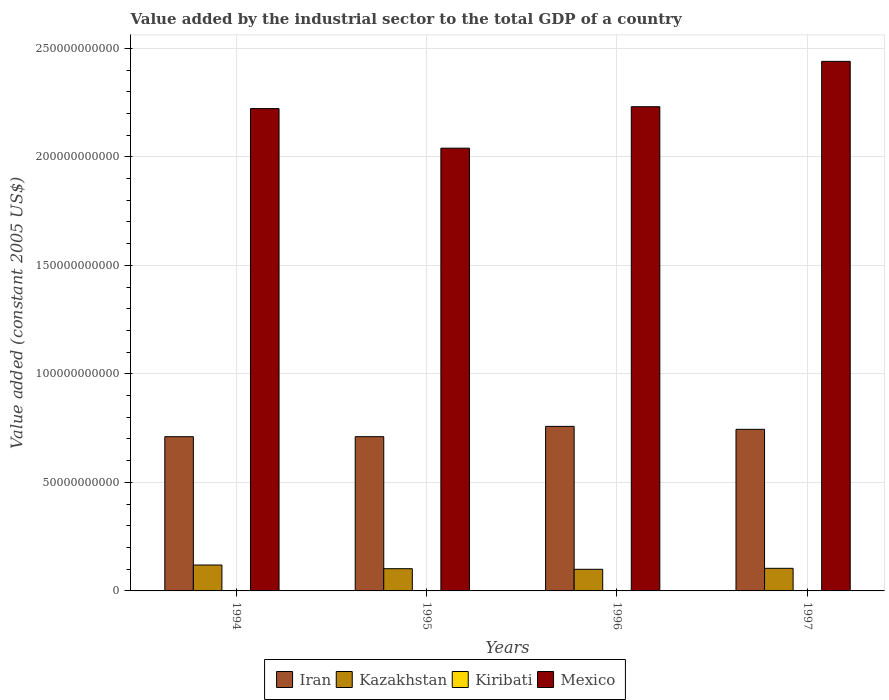How many different coloured bars are there?
Your answer should be compact. 4. Are the number of bars per tick equal to the number of legend labels?
Give a very brief answer. Yes. How many bars are there on the 2nd tick from the right?
Give a very brief answer. 4. In how many cases, is the number of bars for a given year not equal to the number of legend labels?
Provide a succinct answer. 0. What is the value added by the industrial sector in Kiribati in 1996?
Your answer should be compact. 4.96e+06. Across all years, what is the maximum value added by the industrial sector in Mexico?
Your answer should be compact. 2.44e+11. Across all years, what is the minimum value added by the industrial sector in Kiribati?
Your answer should be compact. 4.96e+06. What is the total value added by the industrial sector in Mexico in the graph?
Ensure brevity in your answer.  8.93e+11. What is the difference between the value added by the industrial sector in Mexico in 1994 and that in 1997?
Offer a terse response. -2.18e+1. What is the difference between the value added by the industrial sector in Kazakhstan in 1996 and the value added by the industrial sector in Kiribati in 1995?
Offer a very short reply. 9.96e+09. What is the average value added by the industrial sector in Kazakhstan per year?
Ensure brevity in your answer.  1.06e+1. In the year 1994, what is the difference between the value added by the industrial sector in Kiribati and value added by the industrial sector in Iran?
Provide a short and direct response. -7.11e+1. In how many years, is the value added by the industrial sector in Kazakhstan greater than 40000000000 US$?
Ensure brevity in your answer.  0. What is the ratio of the value added by the industrial sector in Kiribati in 1994 to that in 1997?
Provide a succinct answer. 0.96. Is the value added by the industrial sector in Iran in 1994 less than that in 1996?
Your answer should be very brief. Yes. Is the difference between the value added by the industrial sector in Kiribati in 1995 and 1997 greater than the difference between the value added by the industrial sector in Iran in 1995 and 1997?
Your response must be concise. Yes. What is the difference between the highest and the second highest value added by the industrial sector in Mexico?
Offer a very short reply. 2.09e+1. What is the difference between the highest and the lowest value added by the industrial sector in Kiribati?
Provide a succinct answer. 2.42e+05. Is the sum of the value added by the industrial sector in Kiribati in 1996 and 1997 greater than the maximum value added by the industrial sector in Iran across all years?
Offer a very short reply. No. What does the 1st bar from the left in 1997 represents?
Give a very brief answer. Iran. What does the 4th bar from the right in 1994 represents?
Keep it short and to the point. Iran. Is it the case that in every year, the sum of the value added by the industrial sector in Mexico and value added by the industrial sector in Kazakhstan is greater than the value added by the industrial sector in Kiribati?
Make the answer very short. Yes. How many bars are there?
Keep it short and to the point. 16. Are the values on the major ticks of Y-axis written in scientific E-notation?
Make the answer very short. No. Does the graph contain any zero values?
Provide a short and direct response. No. Does the graph contain grids?
Your answer should be very brief. Yes. How many legend labels are there?
Offer a terse response. 4. What is the title of the graph?
Your response must be concise. Value added by the industrial sector to the total GDP of a country. What is the label or title of the Y-axis?
Your answer should be very brief. Value added (constant 2005 US$). What is the Value added (constant 2005 US$) of Iran in 1994?
Your response must be concise. 7.11e+1. What is the Value added (constant 2005 US$) of Kazakhstan in 1994?
Your answer should be very brief. 1.19e+1. What is the Value added (constant 2005 US$) in Kiribati in 1994?
Your answer should be compact. 4.98e+06. What is the Value added (constant 2005 US$) of Mexico in 1994?
Your answer should be compact. 2.22e+11. What is the Value added (constant 2005 US$) of Iran in 1995?
Ensure brevity in your answer.  7.11e+1. What is the Value added (constant 2005 US$) in Kazakhstan in 1995?
Provide a short and direct response. 1.02e+1. What is the Value added (constant 2005 US$) of Kiribati in 1995?
Ensure brevity in your answer.  4.99e+06. What is the Value added (constant 2005 US$) of Mexico in 1995?
Give a very brief answer. 2.04e+11. What is the Value added (constant 2005 US$) of Iran in 1996?
Provide a succinct answer. 7.58e+1. What is the Value added (constant 2005 US$) of Kazakhstan in 1996?
Keep it short and to the point. 9.96e+09. What is the Value added (constant 2005 US$) in Kiribati in 1996?
Your answer should be compact. 4.96e+06. What is the Value added (constant 2005 US$) in Mexico in 1996?
Make the answer very short. 2.23e+11. What is the Value added (constant 2005 US$) in Iran in 1997?
Your answer should be compact. 7.45e+1. What is the Value added (constant 2005 US$) in Kazakhstan in 1997?
Your answer should be compact. 1.04e+1. What is the Value added (constant 2005 US$) of Kiribati in 1997?
Offer a terse response. 5.20e+06. What is the Value added (constant 2005 US$) of Mexico in 1997?
Your answer should be very brief. 2.44e+11. Across all years, what is the maximum Value added (constant 2005 US$) of Iran?
Provide a succinct answer. 7.58e+1. Across all years, what is the maximum Value added (constant 2005 US$) of Kazakhstan?
Make the answer very short. 1.19e+1. Across all years, what is the maximum Value added (constant 2005 US$) of Kiribati?
Give a very brief answer. 5.20e+06. Across all years, what is the maximum Value added (constant 2005 US$) of Mexico?
Your response must be concise. 2.44e+11. Across all years, what is the minimum Value added (constant 2005 US$) in Iran?
Provide a succinct answer. 7.11e+1. Across all years, what is the minimum Value added (constant 2005 US$) in Kazakhstan?
Ensure brevity in your answer.  9.96e+09. Across all years, what is the minimum Value added (constant 2005 US$) in Kiribati?
Keep it short and to the point. 4.96e+06. Across all years, what is the minimum Value added (constant 2005 US$) in Mexico?
Provide a succinct answer. 2.04e+11. What is the total Value added (constant 2005 US$) of Iran in the graph?
Provide a short and direct response. 2.92e+11. What is the total Value added (constant 2005 US$) of Kazakhstan in the graph?
Give a very brief answer. 4.26e+1. What is the total Value added (constant 2005 US$) of Kiribati in the graph?
Give a very brief answer. 2.01e+07. What is the total Value added (constant 2005 US$) in Mexico in the graph?
Give a very brief answer. 8.93e+11. What is the difference between the Value added (constant 2005 US$) in Iran in 1994 and that in 1995?
Your response must be concise. -5.44e+06. What is the difference between the Value added (constant 2005 US$) in Kazakhstan in 1994 and that in 1995?
Give a very brief answer. 1.70e+09. What is the difference between the Value added (constant 2005 US$) of Kiribati in 1994 and that in 1995?
Provide a succinct answer. -291.44. What is the difference between the Value added (constant 2005 US$) of Mexico in 1994 and that in 1995?
Your answer should be very brief. 1.82e+1. What is the difference between the Value added (constant 2005 US$) of Iran in 1994 and that in 1996?
Your answer should be very brief. -4.75e+09. What is the difference between the Value added (constant 2005 US$) in Kazakhstan in 1994 and that in 1996?
Provide a succinct answer. 1.98e+09. What is the difference between the Value added (constant 2005 US$) of Kiribati in 1994 and that in 1996?
Offer a very short reply. 2.59e+04. What is the difference between the Value added (constant 2005 US$) of Mexico in 1994 and that in 1996?
Keep it short and to the point. -8.65e+08. What is the difference between the Value added (constant 2005 US$) in Iran in 1994 and that in 1997?
Offer a very short reply. -3.39e+09. What is the difference between the Value added (constant 2005 US$) of Kazakhstan in 1994 and that in 1997?
Provide a short and direct response. 1.53e+09. What is the difference between the Value added (constant 2005 US$) in Kiribati in 1994 and that in 1997?
Your answer should be very brief. -2.17e+05. What is the difference between the Value added (constant 2005 US$) of Mexico in 1994 and that in 1997?
Offer a terse response. -2.18e+1. What is the difference between the Value added (constant 2005 US$) of Iran in 1995 and that in 1996?
Provide a succinct answer. -4.74e+09. What is the difference between the Value added (constant 2005 US$) in Kazakhstan in 1995 and that in 1996?
Give a very brief answer. 2.82e+08. What is the difference between the Value added (constant 2005 US$) in Kiribati in 1995 and that in 1996?
Your response must be concise. 2.62e+04. What is the difference between the Value added (constant 2005 US$) of Mexico in 1995 and that in 1996?
Offer a very short reply. -1.91e+1. What is the difference between the Value added (constant 2005 US$) in Iran in 1995 and that in 1997?
Keep it short and to the point. -3.39e+09. What is the difference between the Value added (constant 2005 US$) in Kazakhstan in 1995 and that in 1997?
Make the answer very short. -1.69e+08. What is the difference between the Value added (constant 2005 US$) of Kiribati in 1995 and that in 1997?
Your answer should be compact. -2.16e+05. What is the difference between the Value added (constant 2005 US$) of Mexico in 1995 and that in 1997?
Offer a terse response. -4.00e+1. What is the difference between the Value added (constant 2005 US$) in Iran in 1996 and that in 1997?
Offer a very short reply. 1.35e+09. What is the difference between the Value added (constant 2005 US$) of Kazakhstan in 1996 and that in 1997?
Keep it short and to the point. -4.52e+08. What is the difference between the Value added (constant 2005 US$) of Kiribati in 1996 and that in 1997?
Keep it short and to the point. -2.42e+05. What is the difference between the Value added (constant 2005 US$) of Mexico in 1996 and that in 1997?
Provide a succinct answer. -2.09e+1. What is the difference between the Value added (constant 2005 US$) in Iran in 1994 and the Value added (constant 2005 US$) in Kazakhstan in 1995?
Offer a very short reply. 6.08e+1. What is the difference between the Value added (constant 2005 US$) in Iran in 1994 and the Value added (constant 2005 US$) in Kiribati in 1995?
Ensure brevity in your answer.  7.11e+1. What is the difference between the Value added (constant 2005 US$) in Iran in 1994 and the Value added (constant 2005 US$) in Mexico in 1995?
Your answer should be compact. -1.33e+11. What is the difference between the Value added (constant 2005 US$) of Kazakhstan in 1994 and the Value added (constant 2005 US$) of Kiribati in 1995?
Provide a succinct answer. 1.19e+1. What is the difference between the Value added (constant 2005 US$) of Kazakhstan in 1994 and the Value added (constant 2005 US$) of Mexico in 1995?
Your answer should be compact. -1.92e+11. What is the difference between the Value added (constant 2005 US$) in Kiribati in 1994 and the Value added (constant 2005 US$) in Mexico in 1995?
Your answer should be very brief. -2.04e+11. What is the difference between the Value added (constant 2005 US$) in Iran in 1994 and the Value added (constant 2005 US$) in Kazakhstan in 1996?
Your response must be concise. 6.11e+1. What is the difference between the Value added (constant 2005 US$) of Iran in 1994 and the Value added (constant 2005 US$) of Kiribati in 1996?
Give a very brief answer. 7.11e+1. What is the difference between the Value added (constant 2005 US$) in Iran in 1994 and the Value added (constant 2005 US$) in Mexico in 1996?
Provide a short and direct response. -1.52e+11. What is the difference between the Value added (constant 2005 US$) in Kazakhstan in 1994 and the Value added (constant 2005 US$) in Kiribati in 1996?
Provide a short and direct response. 1.19e+1. What is the difference between the Value added (constant 2005 US$) of Kazakhstan in 1994 and the Value added (constant 2005 US$) of Mexico in 1996?
Offer a very short reply. -2.11e+11. What is the difference between the Value added (constant 2005 US$) in Kiribati in 1994 and the Value added (constant 2005 US$) in Mexico in 1996?
Ensure brevity in your answer.  -2.23e+11. What is the difference between the Value added (constant 2005 US$) of Iran in 1994 and the Value added (constant 2005 US$) of Kazakhstan in 1997?
Your response must be concise. 6.06e+1. What is the difference between the Value added (constant 2005 US$) of Iran in 1994 and the Value added (constant 2005 US$) of Kiribati in 1997?
Keep it short and to the point. 7.11e+1. What is the difference between the Value added (constant 2005 US$) in Iran in 1994 and the Value added (constant 2005 US$) in Mexico in 1997?
Provide a short and direct response. -1.73e+11. What is the difference between the Value added (constant 2005 US$) in Kazakhstan in 1994 and the Value added (constant 2005 US$) in Kiribati in 1997?
Provide a succinct answer. 1.19e+1. What is the difference between the Value added (constant 2005 US$) in Kazakhstan in 1994 and the Value added (constant 2005 US$) in Mexico in 1997?
Give a very brief answer. -2.32e+11. What is the difference between the Value added (constant 2005 US$) of Kiribati in 1994 and the Value added (constant 2005 US$) of Mexico in 1997?
Keep it short and to the point. -2.44e+11. What is the difference between the Value added (constant 2005 US$) of Iran in 1995 and the Value added (constant 2005 US$) of Kazakhstan in 1996?
Make the answer very short. 6.11e+1. What is the difference between the Value added (constant 2005 US$) of Iran in 1995 and the Value added (constant 2005 US$) of Kiribati in 1996?
Provide a succinct answer. 7.11e+1. What is the difference between the Value added (constant 2005 US$) in Iran in 1995 and the Value added (constant 2005 US$) in Mexico in 1996?
Provide a short and direct response. -1.52e+11. What is the difference between the Value added (constant 2005 US$) of Kazakhstan in 1995 and the Value added (constant 2005 US$) of Kiribati in 1996?
Ensure brevity in your answer.  1.02e+1. What is the difference between the Value added (constant 2005 US$) in Kazakhstan in 1995 and the Value added (constant 2005 US$) in Mexico in 1996?
Your answer should be very brief. -2.13e+11. What is the difference between the Value added (constant 2005 US$) in Kiribati in 1995 and the Value added (constant 2005 US$) in Mexico in 1996?
Your answer should be compact. -2.23e+11. What is the difference between the Value added (constant 2005 US$) in Iran in 1995 and the Value added (constant 2005 US$) in Kazakhstan in 1997?
Provide a short and direct response. 6.07e+1. What is the difference between the Value added (constant 2005 US$) in Iran in 1995 and the Value added (constant 2005 US$) in Kiribati in 1997?
Your answer should be compact. 7.11e+1. What is the difference between the Value added (constant 2005 US$) of Iran in 1995 and the Value added (constant 2005 US$) of Mexico in 1997?
Give a very brief answer. -1.73e+11. What is the difference between the Value added (constant 2005 US$) of Kazakhstan in 1995 and the Value added (constant 2005 US$) of Kiribati in 1997?
Your response must be concise. 1.02e+1. What is the difference between the Value added (constant 2005 US$) in Kazakhstan in 1995 and the Value added (constant 2005 US$) in Mexico in 1997?
Offer a very short reply. -2.34e+11. What is the difference between the Value added (constant 2005 US$) of Kiribati in 1995 and the Value added (constant 2005 US$) of Mexico in 1997?
Give a very brief answer. -2.44e+11. What is the difference between the Value added (constant 2005 US$) in Iran in 1996 and the Value added (constant 2005 US$) in Kazakhstan in 1997?
Offer a very short reply. 6.54e+1. What is the difference between the Value added (constant 2005 US$) of Iran in 1996 and the Value added (constant 2005 US$) of Kiribati in 1997?
Offer a very short reply. 7.58e+1. What is the difference between the Value added (constant 2005 US$) of Iran in 1996 and the Value added (constant 2005 US$) of Mexico in 1997?
Your response must be concise. -1.68e+11. What is the difference between the Value added (constant 2005 US$) of Kazakhstan in 1996 and the Value added (constant 2005 US$) of Kiribati in 1997?
Provide a short and direct response. 9.96e+09. What is the difference between the Value added (constant 2005 US$) of Kazakhstan in 1996 and the Value added (constant 2005 US$) of Mexico in 1997?
Provide a succinct answer. -2.34e+11. What is the difference between the Value added (constant 2005 US$) in Kiribati in 1996 and the Value added (constant 2005 US$) in Mexico in 1997?
Ensure brevity in your answer.  -2.44e+11. What is the average Value added (constant 2005 US$) of Iran per year?
Your response must be concise. 7.31e+1. What is the average Value added (constant 2005 US$) of Kazakhstan per year?
Provide a short and direct response. 1.06e+1. What is the average Value added (constant 2005 US$) of Kiribati per year?
Offer a very short reply. 5.03e+06. What is the average Value added (constant 2005 US$) of Mexico per year?
Provide a short and direct response. 2.23e+11. In the year 1994, what is the difference between the Value added (constant 2005 US$) of Iran and Value added (constant 2005 US$) of Kazakhstan?
Ensure brevity in your answer.  5.91e+1. In the year 1994, what is the difference between the Value added (constant 2005 US$) of Iran and Value added (constant 2005 US$) of Kiribati?
Provide a short and direct response. 7.11e+1. In the year 1994, what is the difference between the Value added (constant 2005 US$) of Iran and Value added (constant 2005 US$) of Mexico?
Provide a succinct answer. -1.51e+11. In the year 1994, what is the difference between the Value added (constant 2005 US$) in Kazakhstan and Value added (constant 2005 US$) in Kiribati?
Your answer should be compact. 1.19e+1. In the year 1994, what is the difference between the Value added (constant 2005 US$) in Kazakhstan and Value added (constant 2005 US$) in Mexico?
Provide a short and direct response. -2.10e+11. In the year 1994, what is the difference between the Value added (constant 2005 US$) of Kiribati and Value added (constant 2005 US$) of Mexico?
Ensure brevity in your answer.  -2.22e+11. In the year 1995, what is the difference between the Value added (constant 2005 US$) in Iran and Value added (constant 2005 US$) in Kazakhstan?
Make the answer very short. 6.08e+1. In the year 1995, what is the difference between the Value added (constant 2005 US$) of Iran and Value added (constant 2005 US$) of Kiribati?
Your answer should be very brief. 7.11e+1. In the year 1995, what is the difference between the Value added (constant 2005 US$) of Iran and Value added (constant 2005 US$) of Mexico?
Provide a succinct answer. -1.33e+11. In the year 1995, what is the difference between the Value added (constant 2005 US$) of Kazakhstan and Value added (constant 2005 US$) of Kiribati?
Your answer should be very brief. 1.02e+1. In the year 1995, what is the difference between the Value added (constant 2005 US$) in Kazakhstan and Value added (constant 2005 US$) in Mexico?
Ensure brevity in your answer.  -1.94e+11. In the year 1995, what is the difference between the Value added (constant 2005 US$) in Kiribati and Value added (constant 2005 US$) in Mexico?
Your answer should be compact. -2.04e+11. In the year 1996, what is the difference between the Value added (constant 2005 US$) in Iran and Value added (constant 2005 US$) in Kazakhstan?
Offer a very short reply. 6.58e+1. In the year 1996, what is the difference between the Value added (constant 2005 US$) of Iran and Value added (constant 2005 US$) of Kiribati?
Provide a short and direct response. 7.58e+1. In the year 1996, what is the difference between the Value added (constant 2005 US$) in Iran and Value added (constant 2005 US$) in Mexico?
Offer a very short reply. -1.47e+11. In the year 1996, what is the difference between the Value added (constant 2005 US$) of Kazakhstan and Value added (constant 2005 US$) of Kiribati?
Offer a terse response. 9.96e+09. In the year 1996, what is the difference between the Value added (constant 2005 US$) of Kazakhstan and Value added (constant 2005 US$) of Mexico?
Your answer should be very brief. -2.13e+11. In the year 1996, what is the difference between the Value added (constant 2005 US$) of Kiribati and Value added (constant 2005 US$) of Mexico?
Keep it short and to the point. -2.23e+11. In the year 1997, what is the difference between the Value added (constant 2005 US$) in Iran and Value added (constant 2005 US$) in Kazakhstan?
Your answer should be very brief. 6.40e+1. In the year 1997, what is the difference between the Value added (constant 2005 US$) in Iran and Value added (constant 2005 US$) in Kiribati?
Ensure brevity in your answer.  7.45e+1. In the year 1997, what is the difference between the Value added (constant 2005 US$) in Iran and Value added (constant 2005 US$) in Mexico?
Your response must be concise. -1.70e+11. In the year 1997, what is the difference between the Value added (constant 2005 US$) of Kazakhstan and Value added (constant 2005 US$) of Kiribati?
Your answer should be very brief. 1.04e+1. In the year 1997, what is the difference between the Value added (constant 2005 US$) in Kazakhstan and Value added (constant 2005 US$) in Mexico?
Provide a succinct answer. -2.34e+11. In the year 1997, what is the difference between the Value added (constant 2005 US$) of Kiribati and Value added (constant 2005 US$) of Mexico?
Make the answer very short. -2.44e+11. What is the ratio of the Value added (constant 2005 US$) in Iran in 1994 to that in 1995?
Your answer should be compact. 1. What is the ratio of the Value added (constant 2005 US$) in Kazakhstan in 1994 to that in 1995?
Give a very brief answer. 1.17. What is the ratio of the Value added (constant 2005 US$) in Kiribati in 1994 to that in 1995?
Your answer should be very brief. 1. What is the ratio of the Value added (constant 2005 US$) in Mexico in 1994 to that in 1995?
Your response must be concise. 1.09. What is the ratio of the Value added (constant 2005 US$) of Iran in 1994 to that in 1996?
Offer a terse response. 0.94. What is the ratio of the Value added (constant 2005 US$) in Kazakhstan in 1994 to that in 1996?
Ensure brevity in your answer.  1.2. What is the ratio of the Value added (constant 2005 US$) in Mexico in 1994 to that in 1996?
Provide a succinct answer. 1. What is the ratio of the Value added (constant 2005 US$) of Iran in 1994 to that in 1997?
Keep it short and to the point. 0.95. What is the ratio of the Value added (constant 2005 US$) in Kazakhstan in 1994 to that in 1997?
Your answer should be compact. 1.15. What is the ratio of the Value added (constant 2005 US$) in Kiribati in 1994 to that in 1997?
Provide a succinct answer. 0.96. What is the ratio of the Value added (constant 2005 US$) of Mexico in 1994 to that in 1997?
Ensure brevity in your answer.  0.91. What is the ratio of the Value added (constant 2005 US$) in Kazakhstan in 1995 to that in 1996?
Provide a succinct answer. 1.03. What is the ratio of the Value added (constant 2005 US$) in Mexico in 1995 to that in 1996?
Offer a terse response. 0.91. What is the ratio of the Value added (constant 2005 US$) in Iran in 1995 to that in 1997?
Your answer should be compact. 0.95. What is the ratio of the Value added (constant 2005 US$) of Kazakhstan in 1995 to that in 1997?
Your answer should be compact. 0.98. What is the ratio of the Value added (constant 2005 US$) in Kiribati in 1995 to that in 1997?
Offer a very short reply. 0.96. What is the ratio of the Value added (constant 2005 US$) of Mexico in 1995 to that in 1997?
Give a very brief answer. 0.84. What is the ratio of the Value added (constant 2005 US$) of Iran in 1996 to that in 1997?
Keep it short and to the point. 1.02. What is the ratio of the Value added (constant 2005 US$) of Kazakhstan in 1996 to that in 1997?
Your answer should be compact. 0.96. What is the ratio of the Value added (constant 2005 US$) in Kiribati in 1996 to that in 1997?
Make the answer very short. 0.95. What is the ratio of the Value added (constant 2005 US$) in Mexico in 1996 to that in 1997?
Your answer should be compact. 0.91. What is the difference between the highest and the second highest Value added (constant 2005 US$) of Iran?
Your answer should be very brief. 1.35e+09. What is the difference between the highest and the second highest Value added (constant 2005 US$) of Kazakhstan?
Give a very brief answer. 1.53e+09. What is the difference between the highest and the second highest Value added (constant 2005 US$) of Kiribati?
Keep it short and to the point. 2.16e+05. What is the difference between the highest and the second highest Value added (constant 2005 US$) of Mexico?
Give a very brief answer. 2.09e+1. What is the difference between the highest and the lowest Value added (constant 2005 US$) in Iran?
Offer a very short reply. 4.75e+09. What is the difference between the highest and the lowest Value added (constant 2005 US$) in Kazakhstan?
Provide a short and direct response. 1.98e+09. What is the difference between the highest and the lowest Value added (constant 2005 US$) of Kiribati?
Offer a very short reply. 2.42e+05. What is the difference between the highest and the lowest Value added (constant 2005 US$) in Mexico?
Keep it short and to the point. 4.00e+1. 